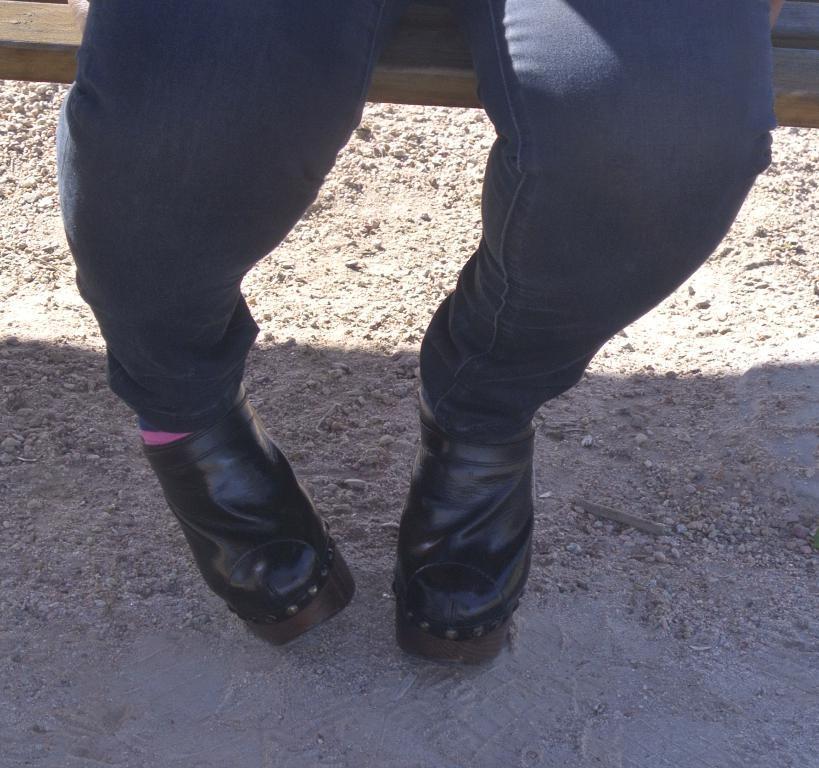In one or two sentences, can you explain what this image depicts? In this image we can see a person wearing shoes is sitting on a bench placed on the ground. 